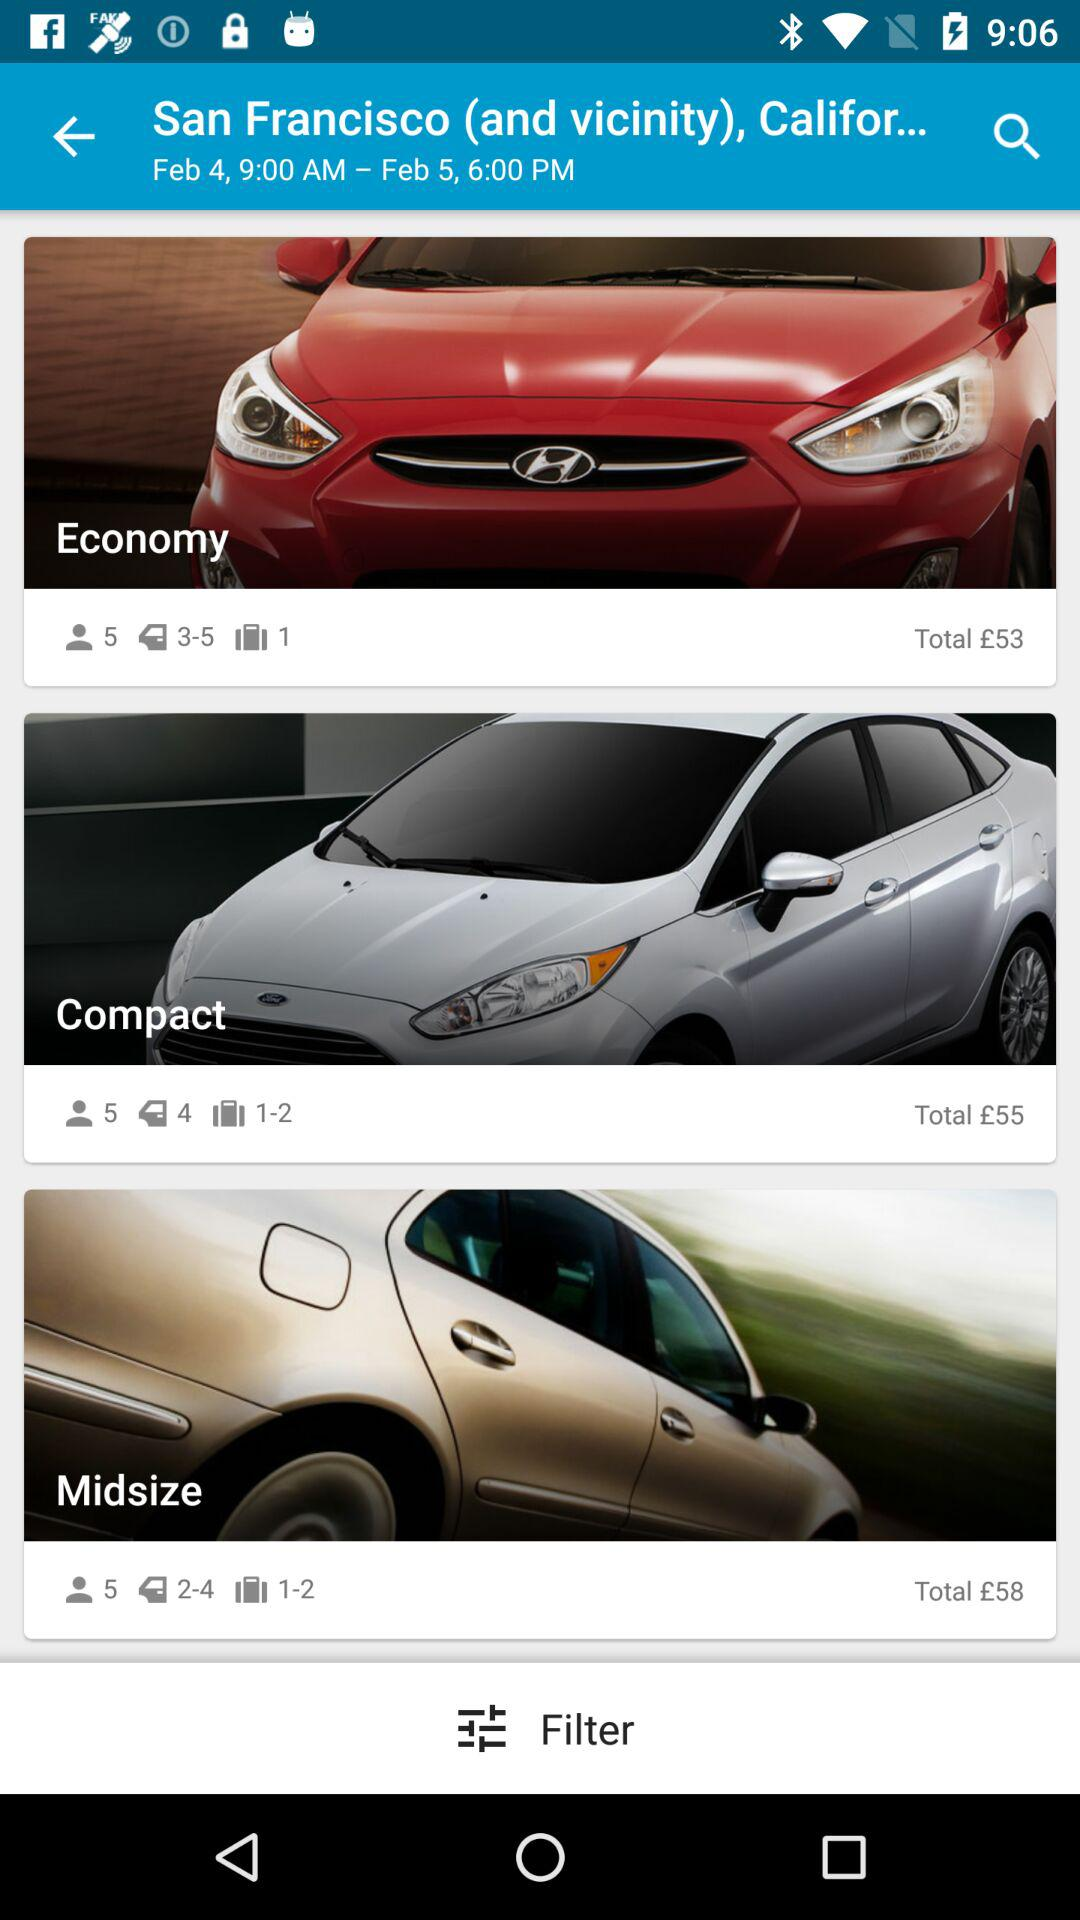How much more is the midsize car than the economy car?
Answer the question using a single word or phrase. £5 